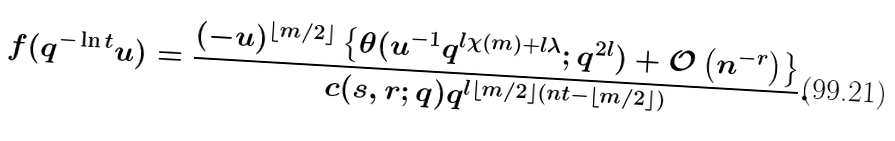<formula> <loc_0><loc_0><loc_500><loc_500>f ( q ^ { - \ln t } u ) = \frac { ( - u ) ^ { \left \lfloor m / 2 \right \rfloor } \left \{ \theta ( u ^ { - 1 } q ^ { l \chi ( m ) + l \lambda } ; q ^ { 2 l } ) + \mathcal { O } \left ( n ^ { - r } \right ) \right \} } { c ( s , r ; q ) q ^ { l \left \lfloor m / 2 \right \rfloor ( n t - \left \lfloor m / 2 \right \rfloor ) } } .</formula> 